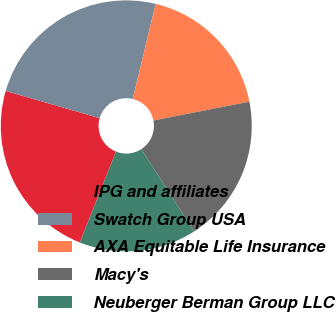Convert chart. <chart><loc_0><loc_0><loc_500><loc_500><pie_chart><fcel>IPG and affiliates<fcel>Swatch Group USA<fcel>AXA Equitable Life Insurance<fcel>Macy's<fcel>Neuberger Berman Group LLC<nl><fcel>23.45%<fcel>24.28%<fcel>18.15%<fcel>18.99%<fcel>15.13%<nl></chart> 